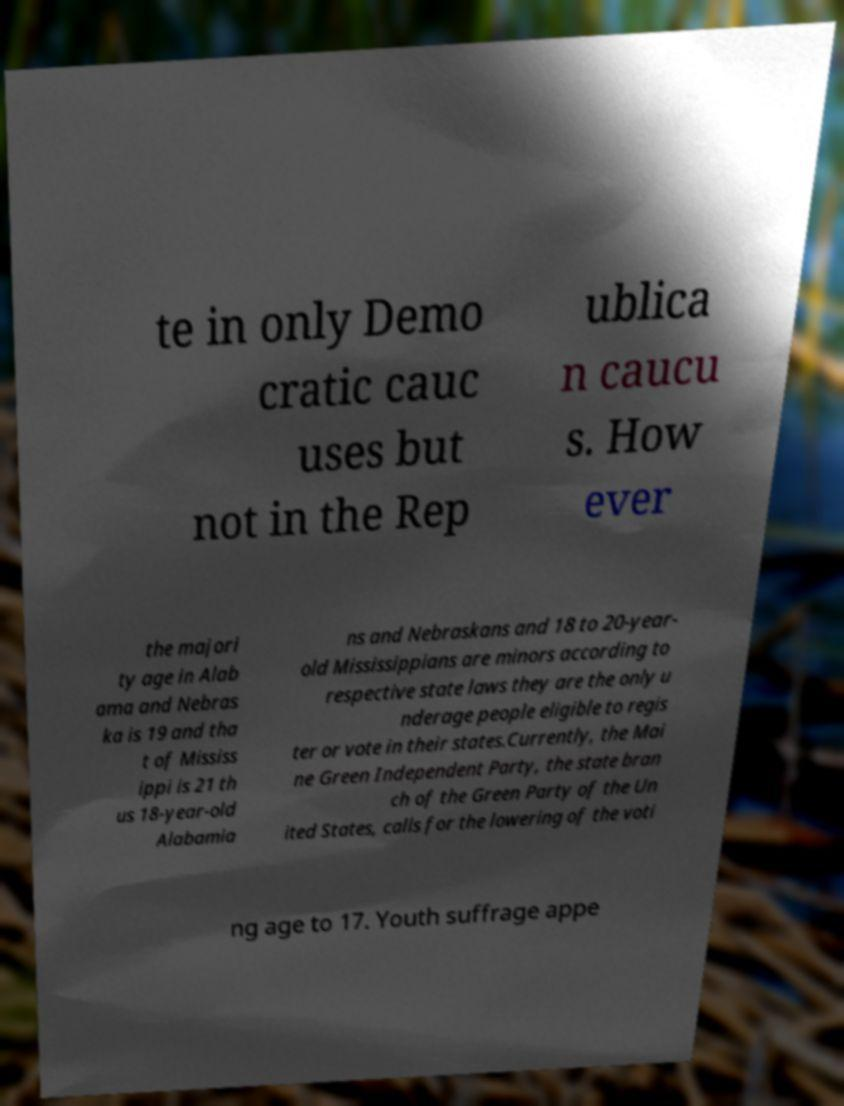Can you accurately transcribe the text from the provided image for me? te in only Demo cratic cauc uses but not in the Rep ublica n caucu s. How ever the majori ty age in Alab ama and Nebras ka is 19 and tha t of Mississ ippi is 21 th us 18-year-old Alabamia ns and Nebraskans and 18 to 20-year- old Mississippians are minors according to respective state laws they are the only u nderage people eligible to regis ter or vote in their states.Currently, the Mai ne Green Independent Party, the state bran ch of the Green Party of the Un ited States, calls for the lowering of the voti ng age to 17. Youth suffrage appe 